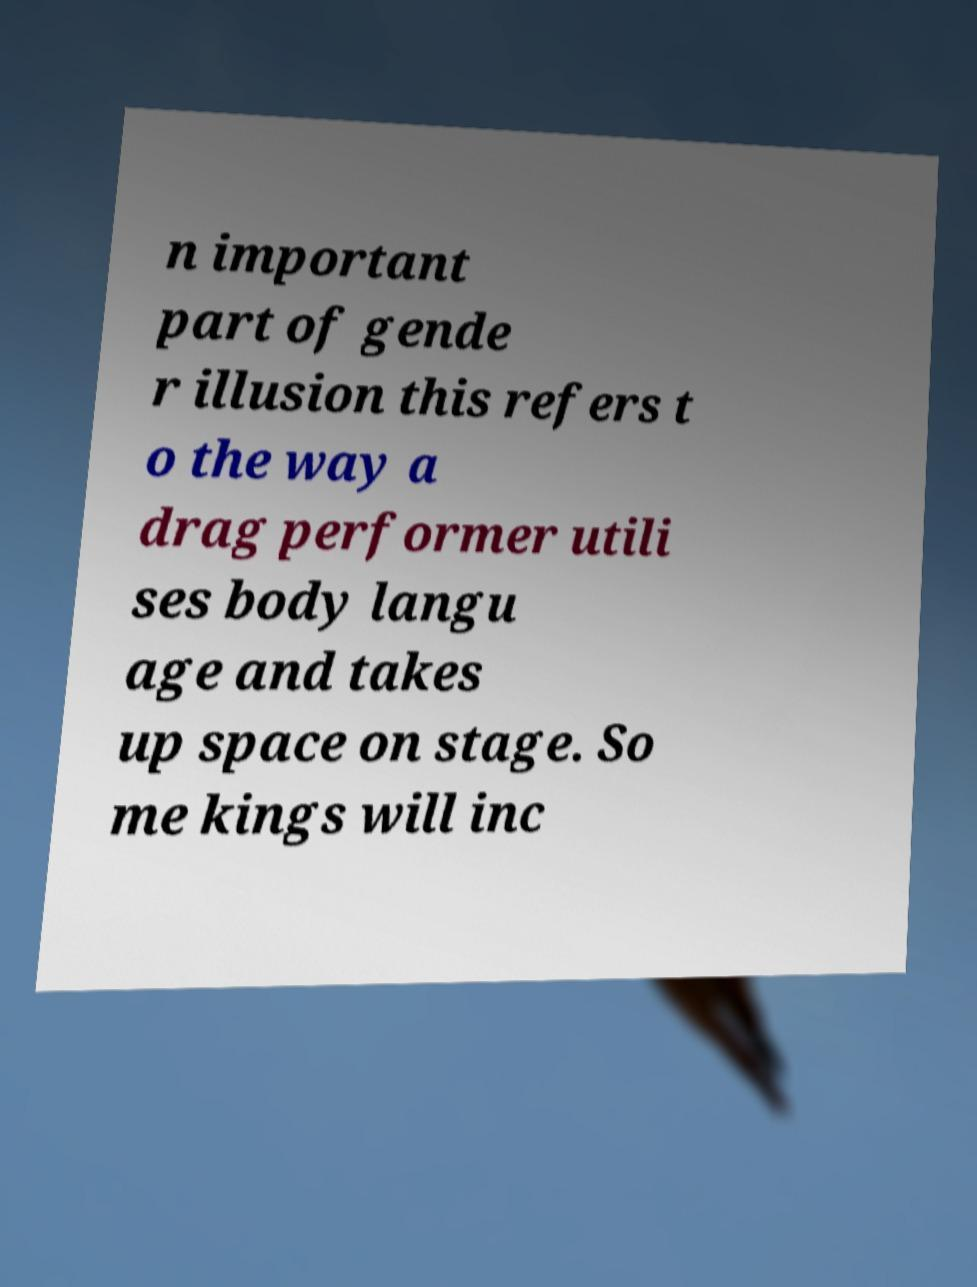Could you extract and type out the text from this image? n important part of gende r illusion this refers t o the way a drag performer utili ses body langu age and takes up space on stage. So me kings will inc 